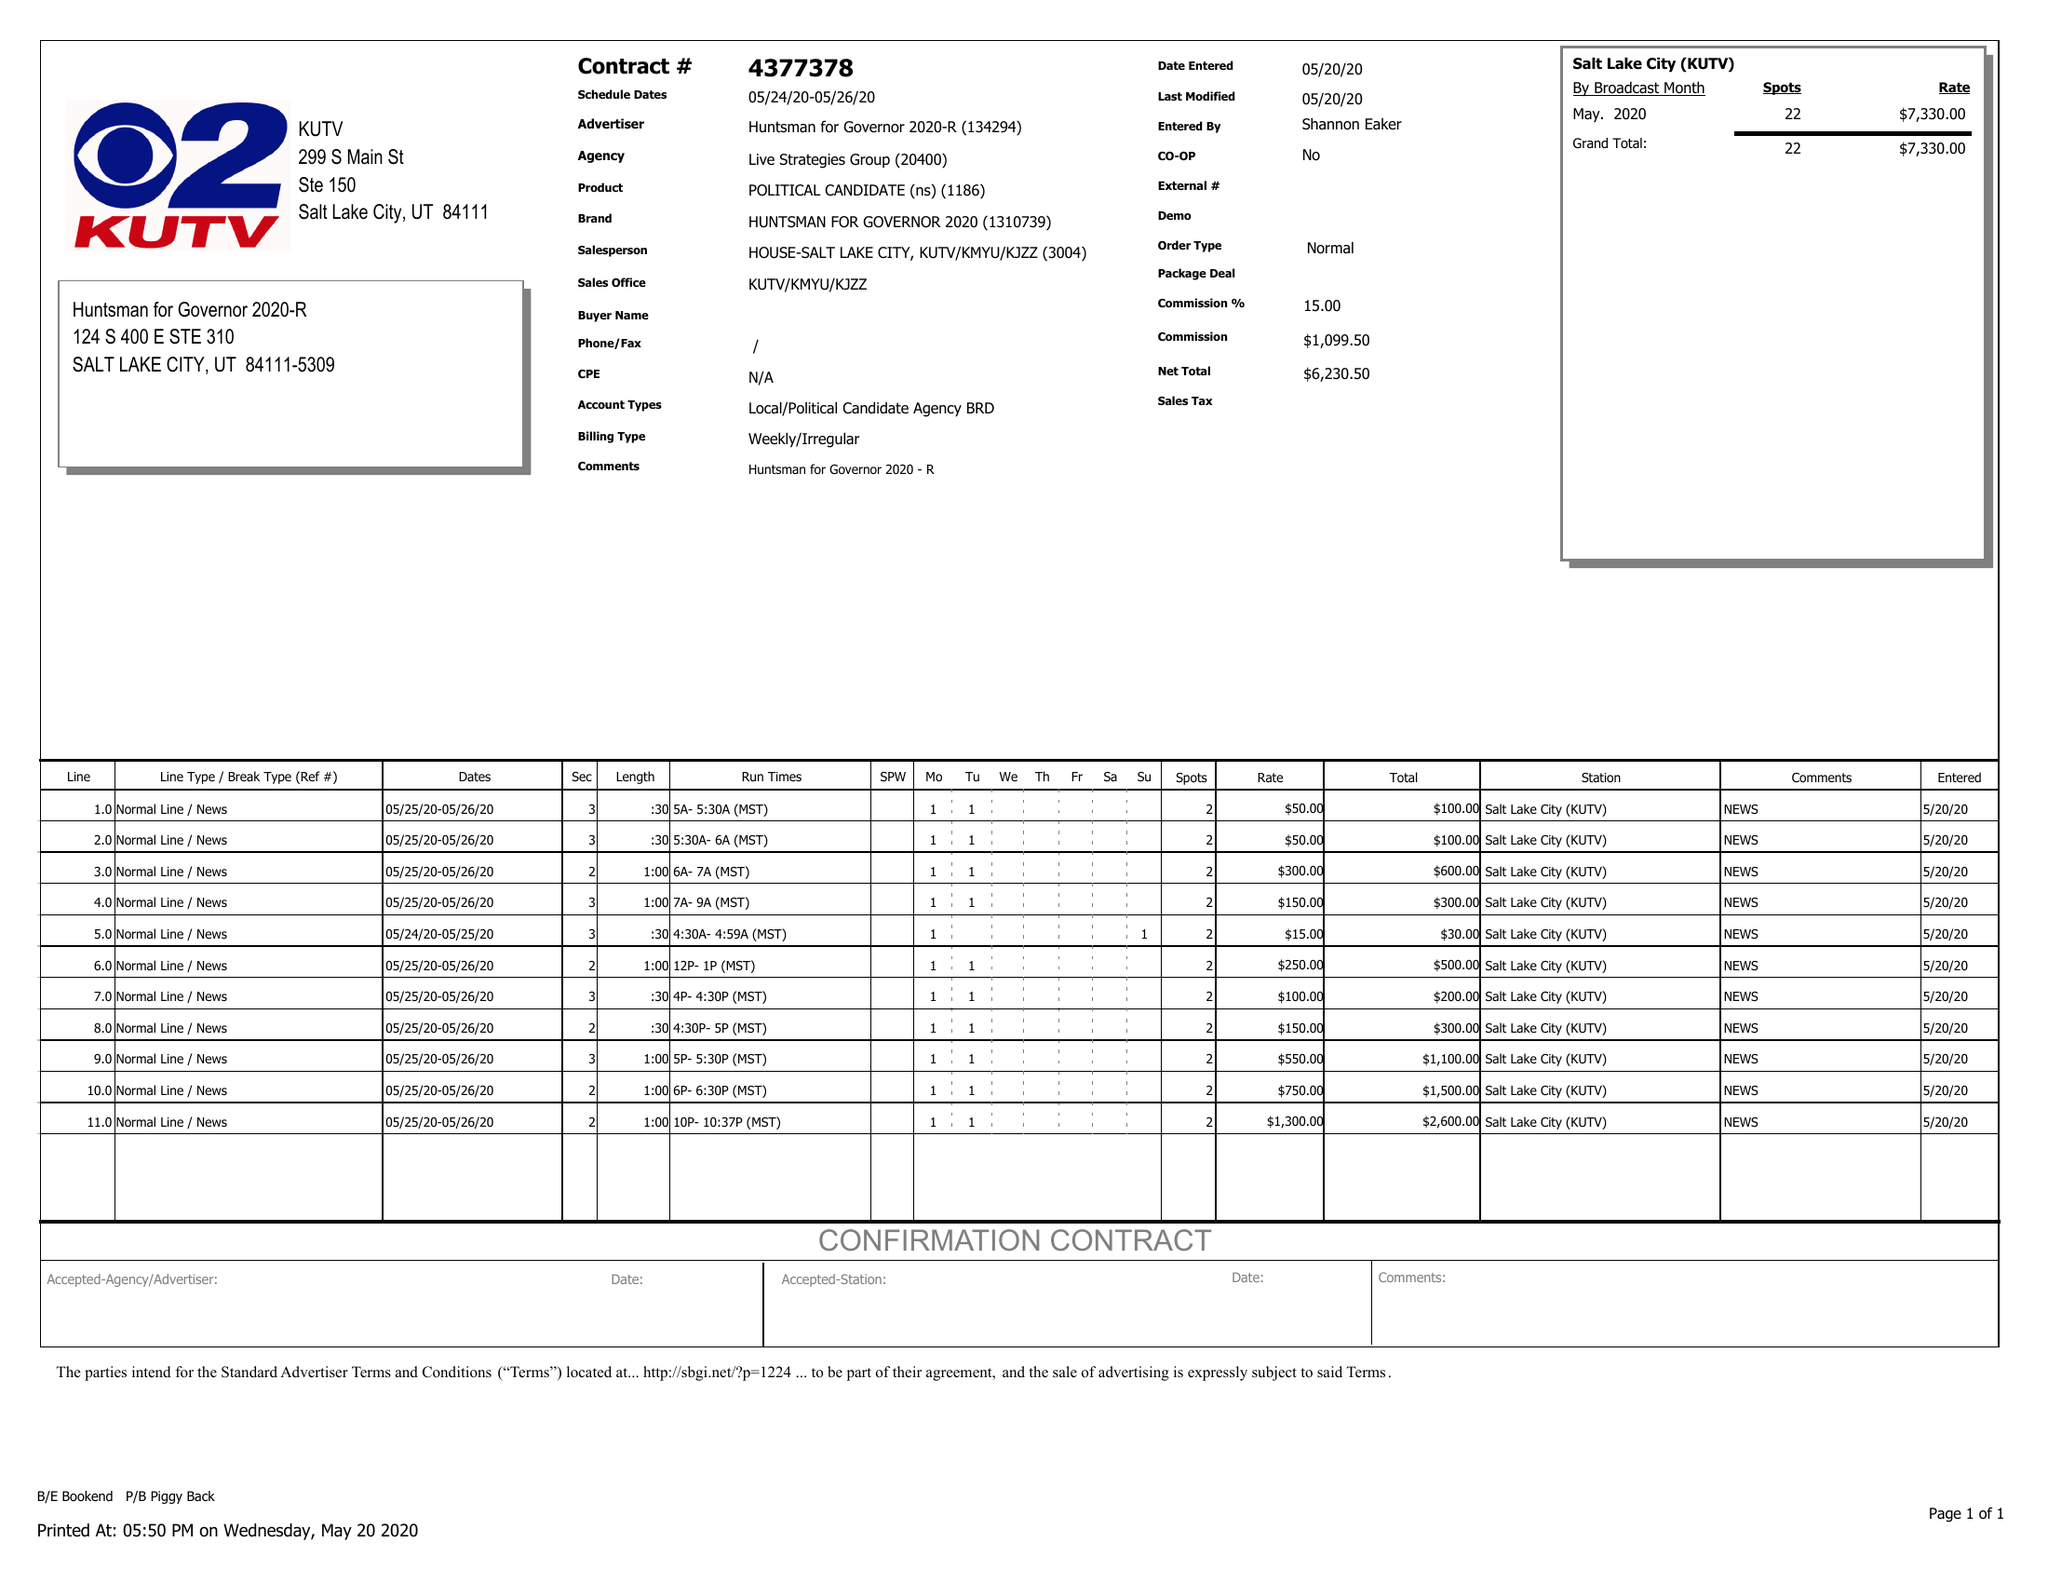What is the value for the contract_num?
Answer the question using a single word or phrase. 4377378 